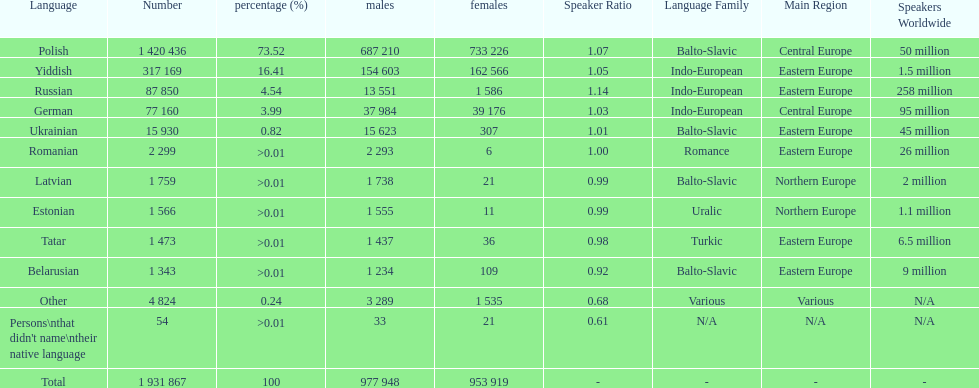What was the foremost language out of those with a percentage above Romanian. I'm looking to parse the entire table for insights. Could you assist me with that? {'header': ['Language', 'Number', 'percentage (%)', 'males', 'females', 'Speaker Ratio', 'Language Family', 'Main Region', 'Speakers Worldwide'], 'rows': [['Polish', '1 420 436', '73.52', '687 210', '733 226', '1.07', 'Balto-Slavic', 'Central Europe', '50 million'], ['Yiddish', '317 169', '16.41', '154 603', '162 566', '1.05', 'Indo-European', 'Eastern Europe', '1.5 million'], ['Russian', '87 850', '4.54', '13 551', '1 586', '1.14', 'Indo-European', 'Eastern Europe', '258 million'], ['German', '77 160', '3.99', '37 984', '39 176', '1.03', 'Indo-European', 'Central Europe', '95 million'], ['Ukrainian', '15 930', '0.82', '15 623', '307', '1.01', 'Balto-Slavic', 'Eastern Europe', '45 million'], ['Romanian', '2 299', '>0.01', '2 293', '6', '1.00', 'Romance', 'Eastern Europe', '26 million'], ['Latvian', '1 759', '>0.01', '1 738', '21', '0.99', 'Balto-Slavic', 'Northern Europe', '2 million'], ['Estonian', '1 566', '>0.01', '1 555', '11', '0.99', 'Uralic', 'Northern Europe', '1.1 million'], ['Tatar', '1 473', '>0.01', '1 437', '36', '0.98', 'Turkic', 'Eastern Europe', '6.5 million'], ['Belarusian', '1 343', '>0.01', '1 234', '109', '0.92', 'Balto-Slavic', 'Eastern Europe', '9 million'], ['Other', '4 824', '0.24', '3 289', '1 535', '0.68', 'Various', 'Various', 'N/A'], ["Persons\\nthat didn't name\\ntheir native language", '54', '>0.01', '33', '21', '0.61', 'N/A', 'N/A', 'N/A'], ['Total', '1 931 867', '100', '977 948', '953 919', '-', '-', '-', '-']]} 